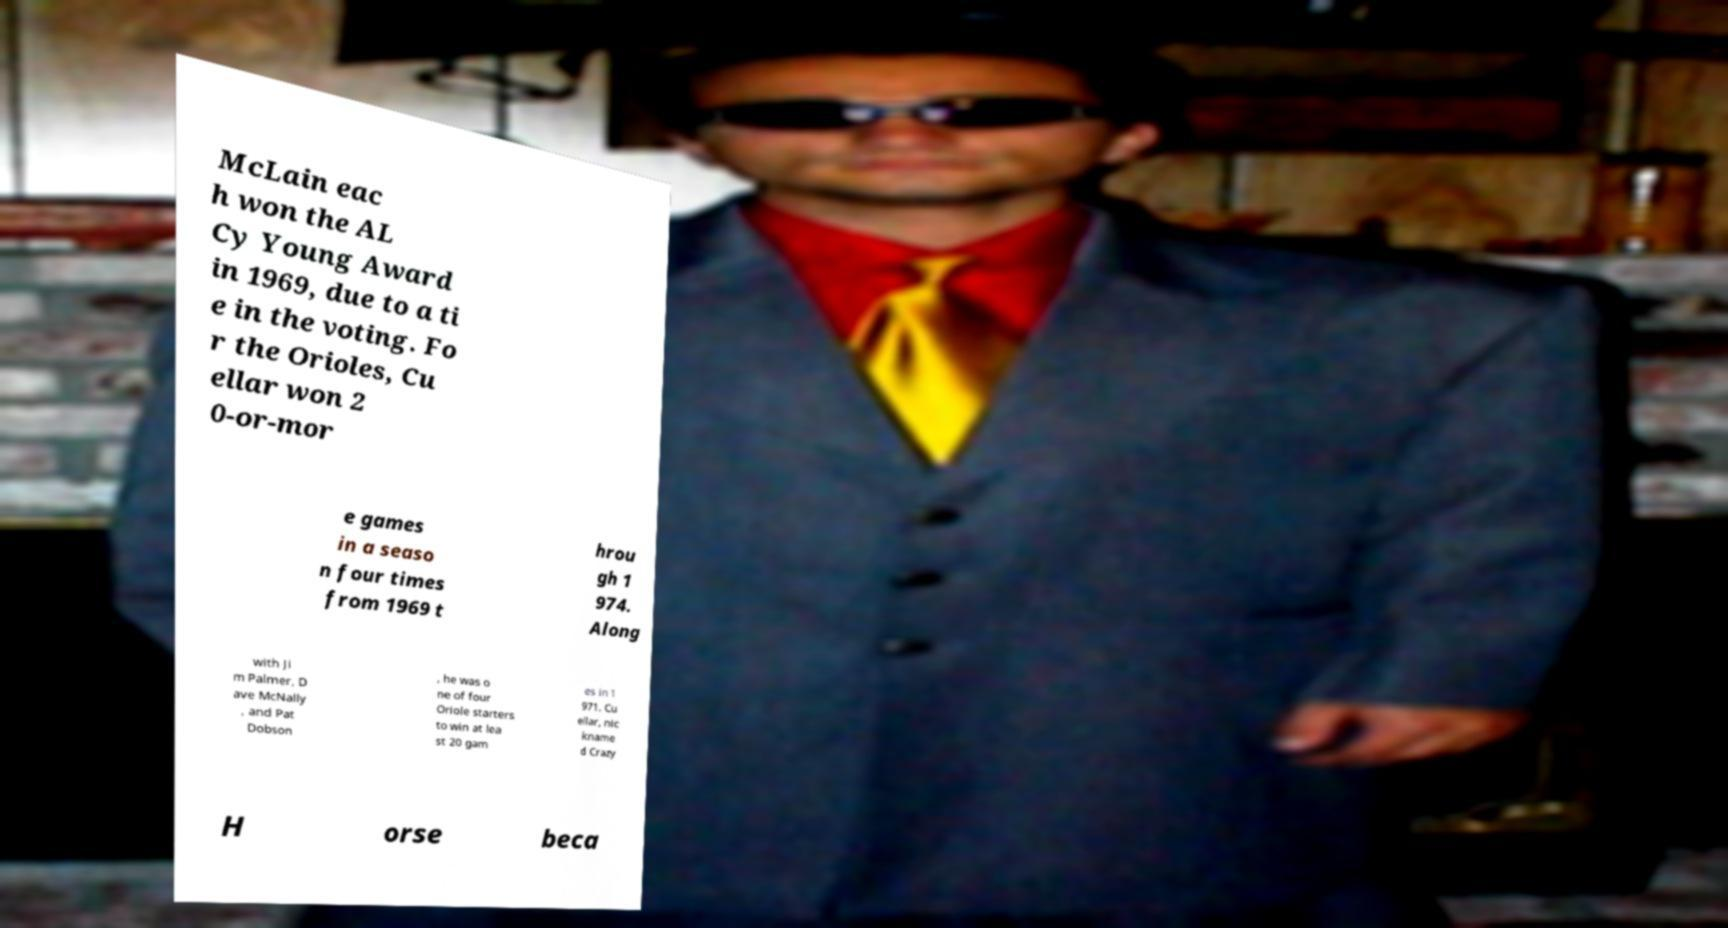There's text embedded in this image that I need extracted. Can you transcribe it verbatim? McLain eac h won the AL Cy Young Award in 1969, due to a ti e in the voting. Fo r the Orioles, Cu ellar won 2 0-or-mor e games in a seaso n four times from 1969 t hrou gh 1 974. Along with Ji m Palmer, D ave McNally , and Pat Dobson , he was o ne of four Oriole starters to win at lea st 20 gam es in 1 971. Cu ellar, nic kname d Crazy H orse beca 